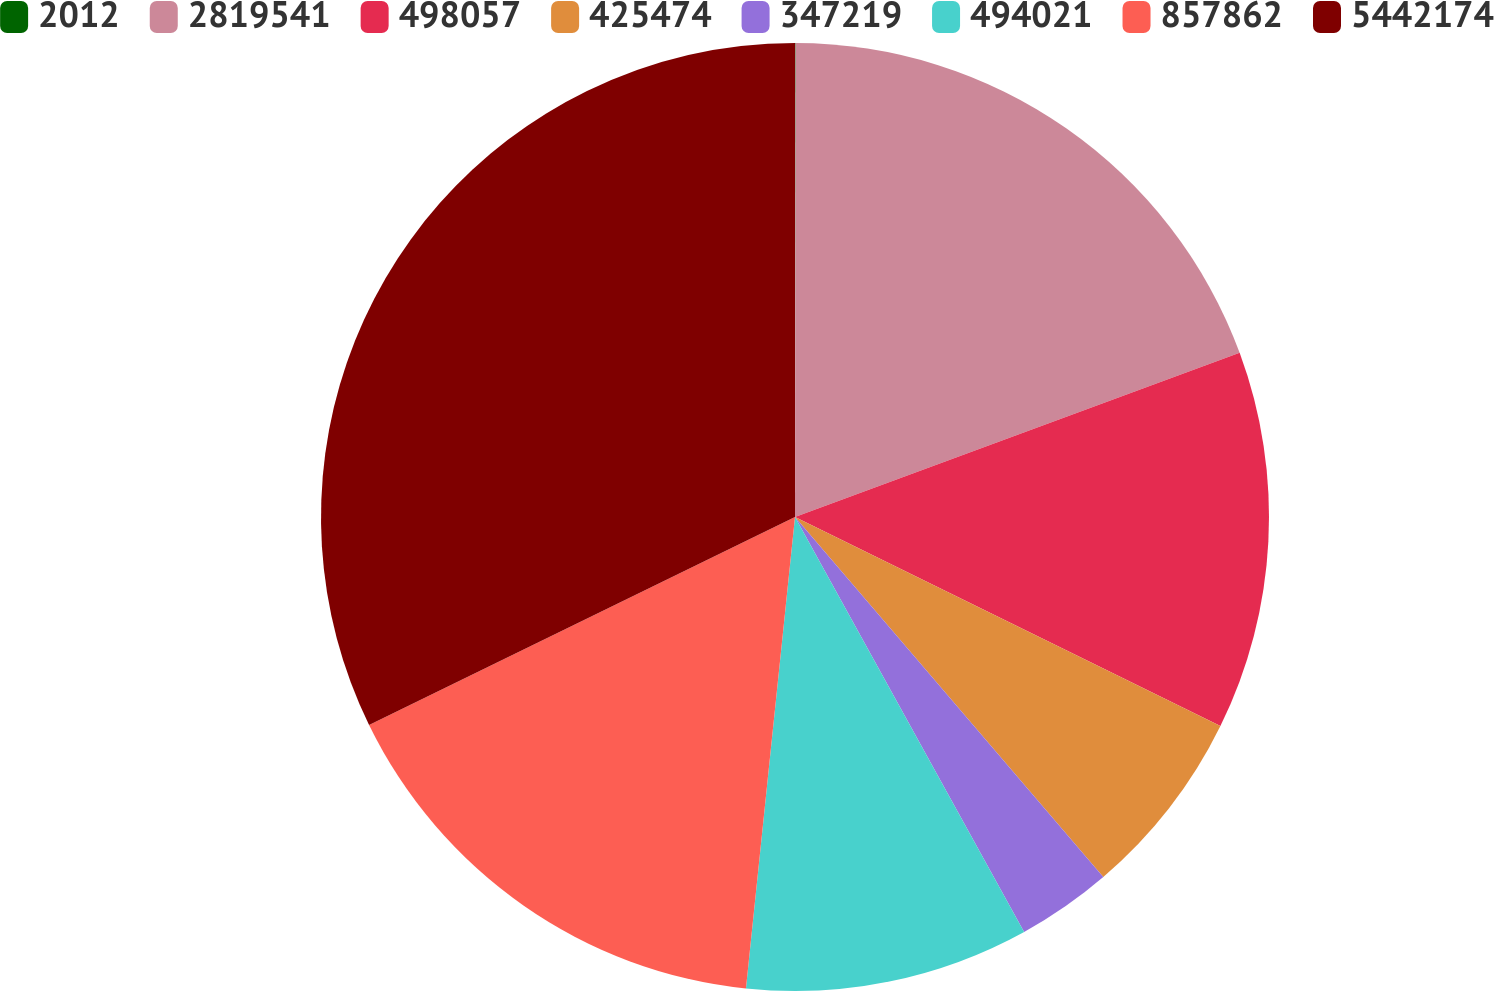Convert chart to OTSL. <chart><loc_0><loc_0><loc_500><loc_500><pie_chart><fcel>2012<fcel>2819541<fcel>498057<fcel>425474<fcel>347219<fcel>494021<fcel>857862<fcel>5442174<nl><fcel>0.02%<fcel>19.35%<fcel>12.9%<fcel>6.46%<fcel>3.24%<fcel>9.68%<fcel>16.12%<fcel>32.23%<nl></chart> 